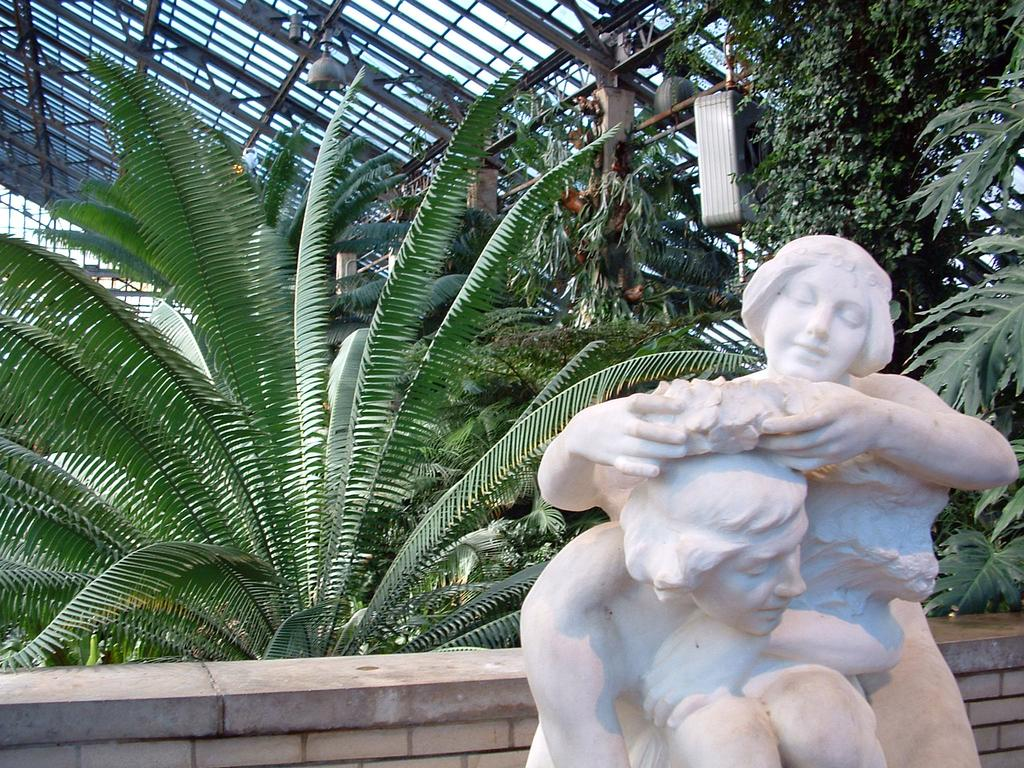What can be seen on the right side of the image? There are statues of two persons on the right side of the image. What is visible in the background of the image? There are plants, a wall, a glass roof, and lights on poles in the background of the image. Can you describe the objects in the background of the image? There are objects in the background of the image, but their specific nature is not mentioned in the provided facts. What type of pig can be seen playing with a plot in the image? There is no pig or plot present in the image. Can you tell me the age of the grandfather in the image? There is no mention of a grandfather or any person in the image, only statues of two persons. 